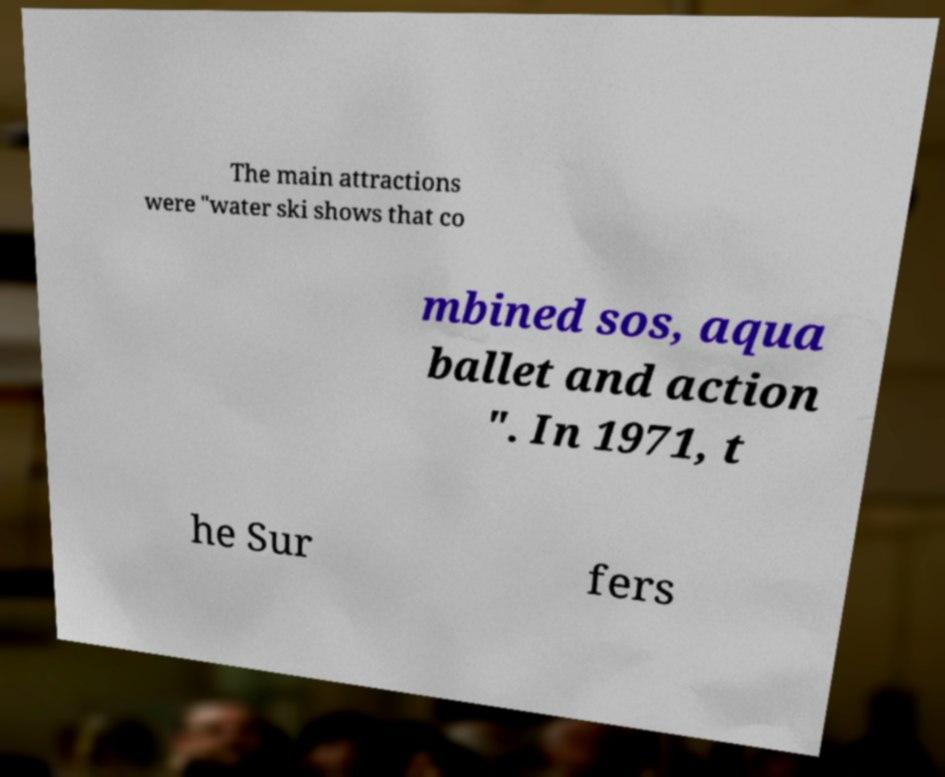Please read and relay the text visible in this image. What does it say? The main attractions were "water ski shows that co mbined sos, aqua ballet and action ". In 1971, t he Sur fers 